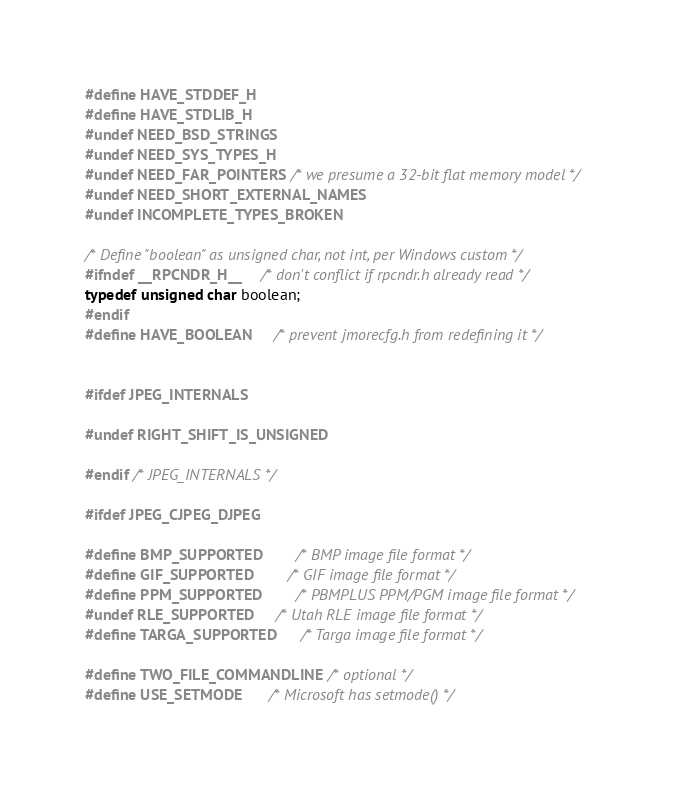Convert code to text. <code><loc_0><loc_0><loc_500><loc_500><_C_>#define HAVE_STDDEF_H
#define HAVE_STDLIB_H
#undef NEED_BSD_STRINGS
#undef NEED_SYS_TYPES_H
#undef NEED_FAR_POINTERS	/* we presume a 32-bit flat memory model */
#undef NEED_SHORT_EXTERNAL_NAMES
#undef INCOMPLETE_TYPES_BROKEN

/* Define "boolean" as unsigned char, not int, per Windows custom */
#ifndef __RPCNDR_H__		/* don't conflict if rpcndr.h already read */
typedef unsigned char boolean;
#endif
#define HAVE_BOOLEAN		/* prevent jmorecfg.h from redefining it */


#ifdef JPEG_INTERNALS

#undef RIGHT_SHIFT_IS_UNSIGNED

#endif /* JPEG_INTERNALS */

#ifdef JPEG_CJPEG_DJPEG

#define BMP_SUPPORTED		/* BMP image file format */
#define GIF_SUPPORTED		/* GIF image file format */
#define PPM_SUPPORTED		/* PBMPLUS PPM/PGM image file format */
#undef RLE_SUPPORTED		/* Utah RLE image file format */
#define TARGA_SUPPORTED		/* Targa image file format */

#define TWO_FILE_COMMANDLINE	/* optional */
#define USE_SETMODE		/* Microsoft has setmode() */</code> 